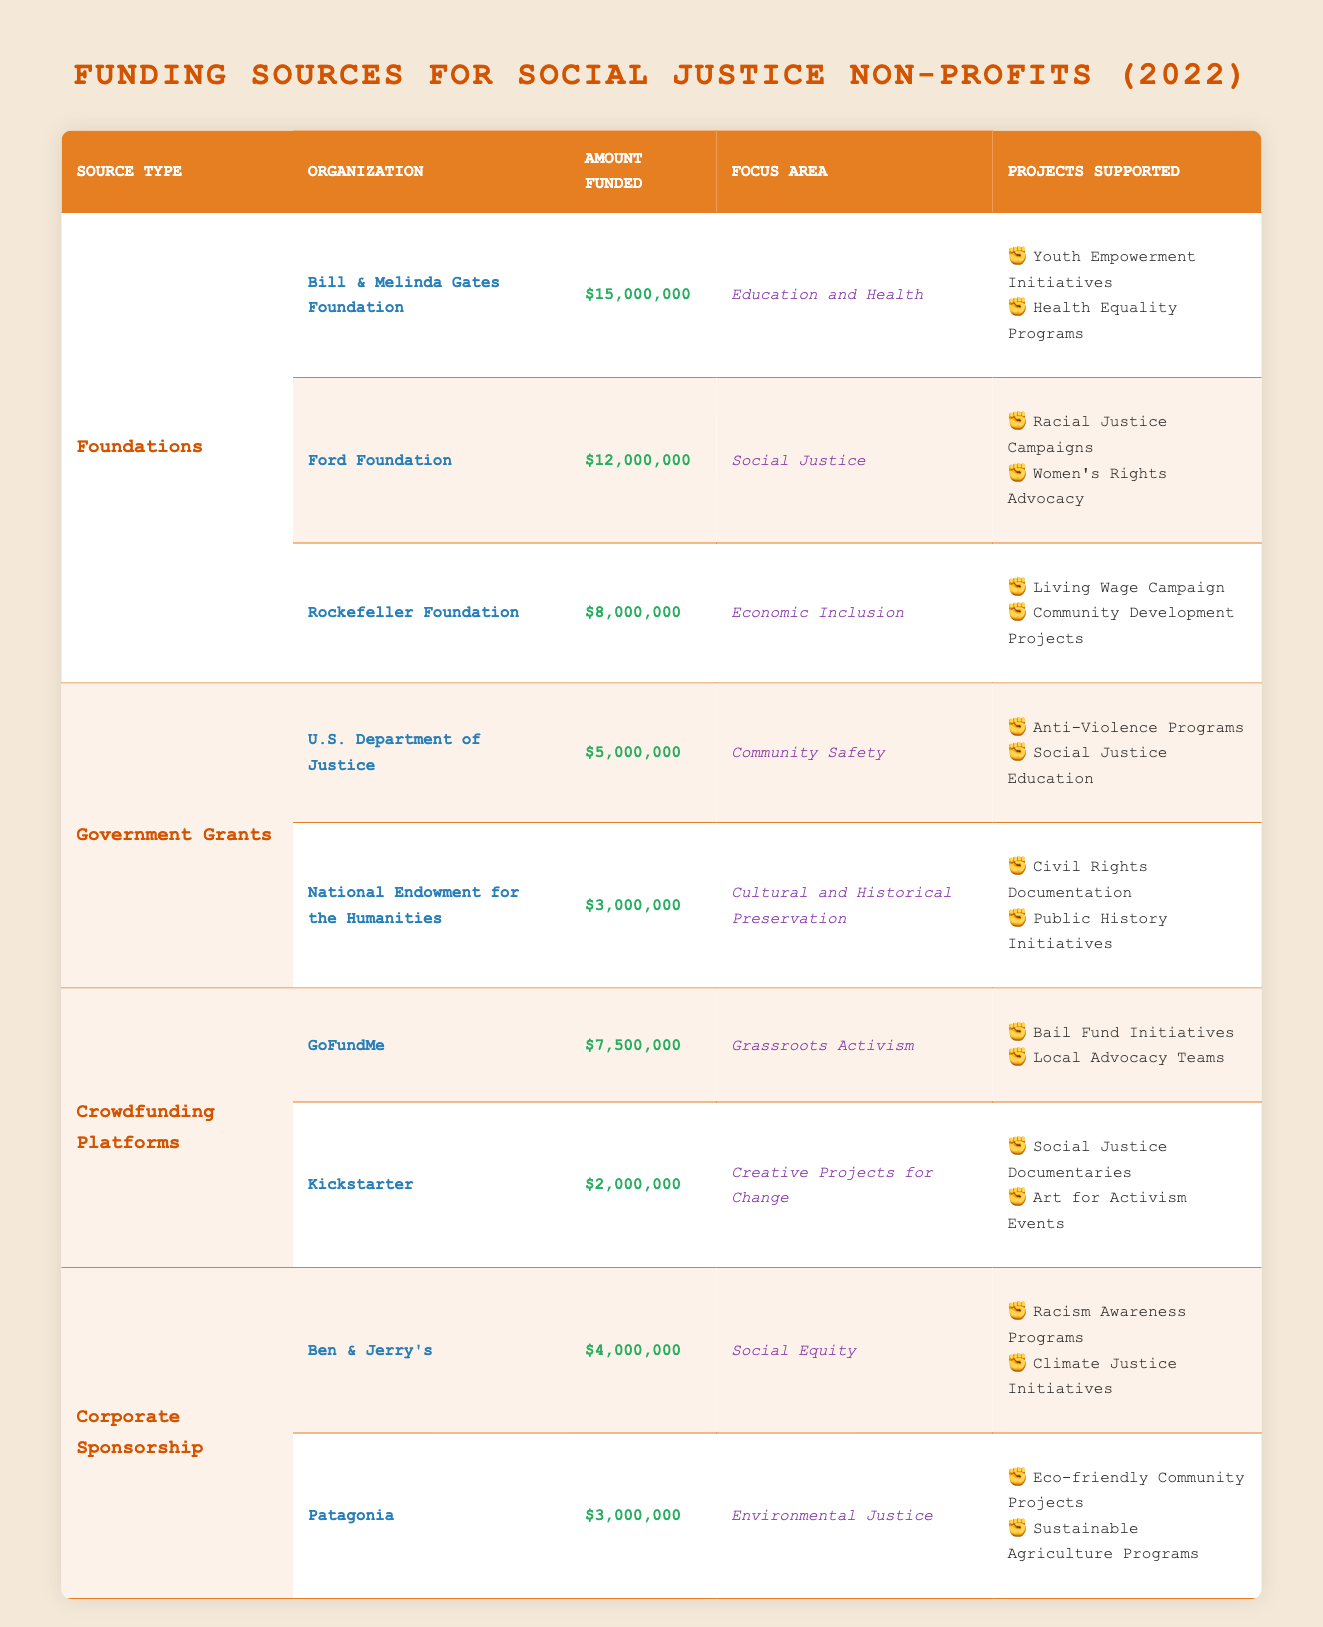What is the total amount funded by the Ford Foundation? The table shows that the Ford Foundation funded $12,000,000. Thus, the total amount funded by the Ford Foundation is simply the value listed in the table under that organization.
Answer: 12,000,000 Which organization from the Foundations category focused on Education and Health? According to the table, the organization that focused on Education and Health is the Bill & Melinda Gates Foundation. This is determined by looking at the "Focus Area" column under the "Foundations" category.
Answer: Bill & Melinda Gates Foundation What is the combined amount funded by Crowdfunding Platforms? The total amount from the Crowdfunding Platforms includes GoFundMe ($7,500,000) and Kickstarter ($2,000,000). Adding these amounts together gives $7,500,000 + $2,000,000 = $9,500,000. Therefore, the combined total amount funded by Crowdfunding Platforms is $9,500,000.
Answer: 9,500,000 Did Patagonia fund any projects related to Social Equity? Checking the table, Patagonia funded projects focused on Environmental Justice and did not have any associations with Social Equity. This means the answer is based on a direct look at the "Focus Area" column under the Corporate Sponsorship category.
Answer: No Which Foundation had the least amount of funding? In the Foundations category, analyzing the amounts funded shows that the Rockefeller Foundation received $8,000,000, which is less than the amounts funded by the other foundations. Thus, the foundation with the least amount of funding is the Rockefeller Foundation.
Answer: Rockefeller Foundation How many projects did the U.S. Department of Justice fund? The table notes that the U.S. Department of Justice supported two projects: Anti-Violence Programs and Social Justice Education. Therefore, the count of projects funded under this organization is two.
Answer: 2 What is the average amount funded by Corporate Sponsorship organizations? There are two organizations in this category - Ben & Jerry's ($4,000,000) and Patagonia ($3,000,000). The total funding is $4,000,000 + $3,000,000 = $7,000,000. Dividing this total by the number of organizations (2) gives an average of $7,000,000 / 2 = $3,500,000. Thus, the average amount funded by Corporate Sponsorship organizations is $3,500,000.
Answer: 3,500,000 Which funding source provided the most financial support in 2022? Looking at the table, the highest amount funded is $15,000,000 by the Bill & Melinda Gates Foundation under the Foundations category. By comparing all funding amounts listed, Bill & Melinda Gates Foundation has the highest funding.
Answer: Bill & Melinda Gates Foundation 